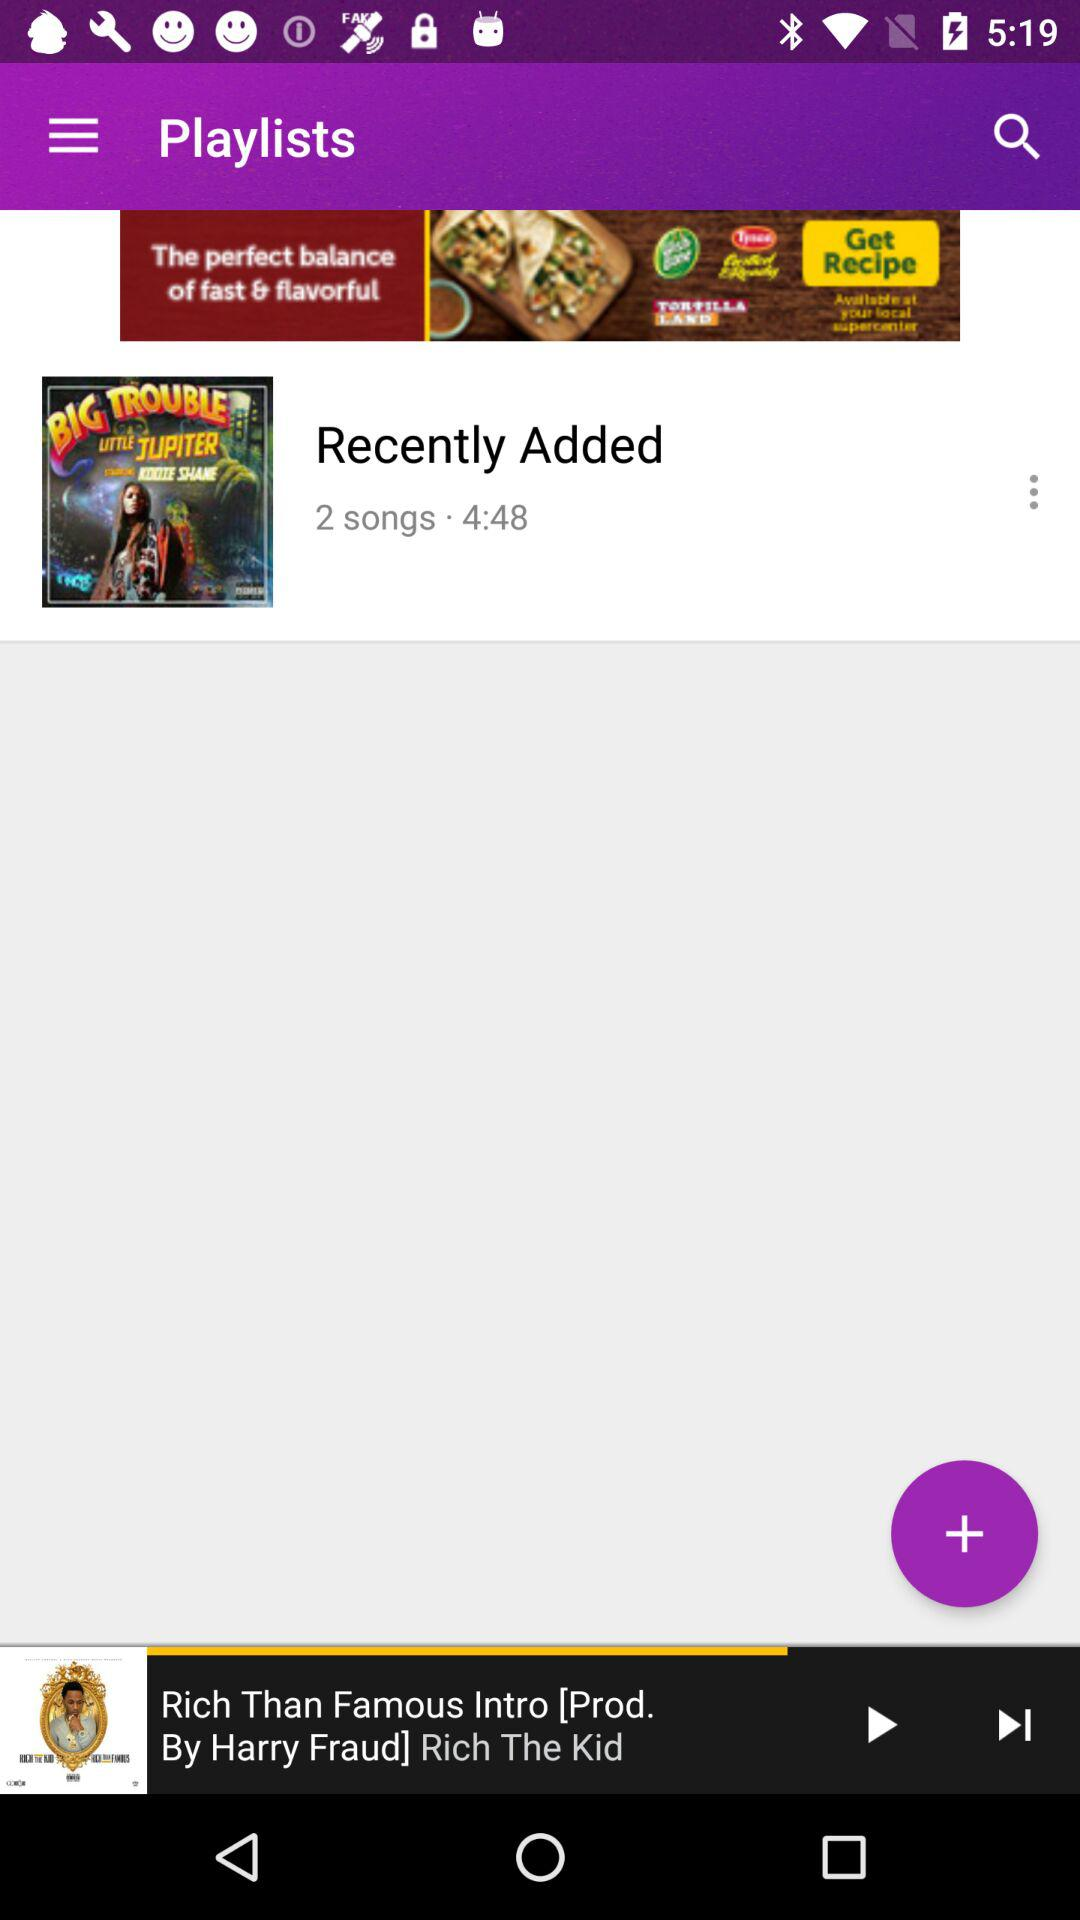Who is the producer of the song which was last played? The producer of the song is Harry Fraud. 